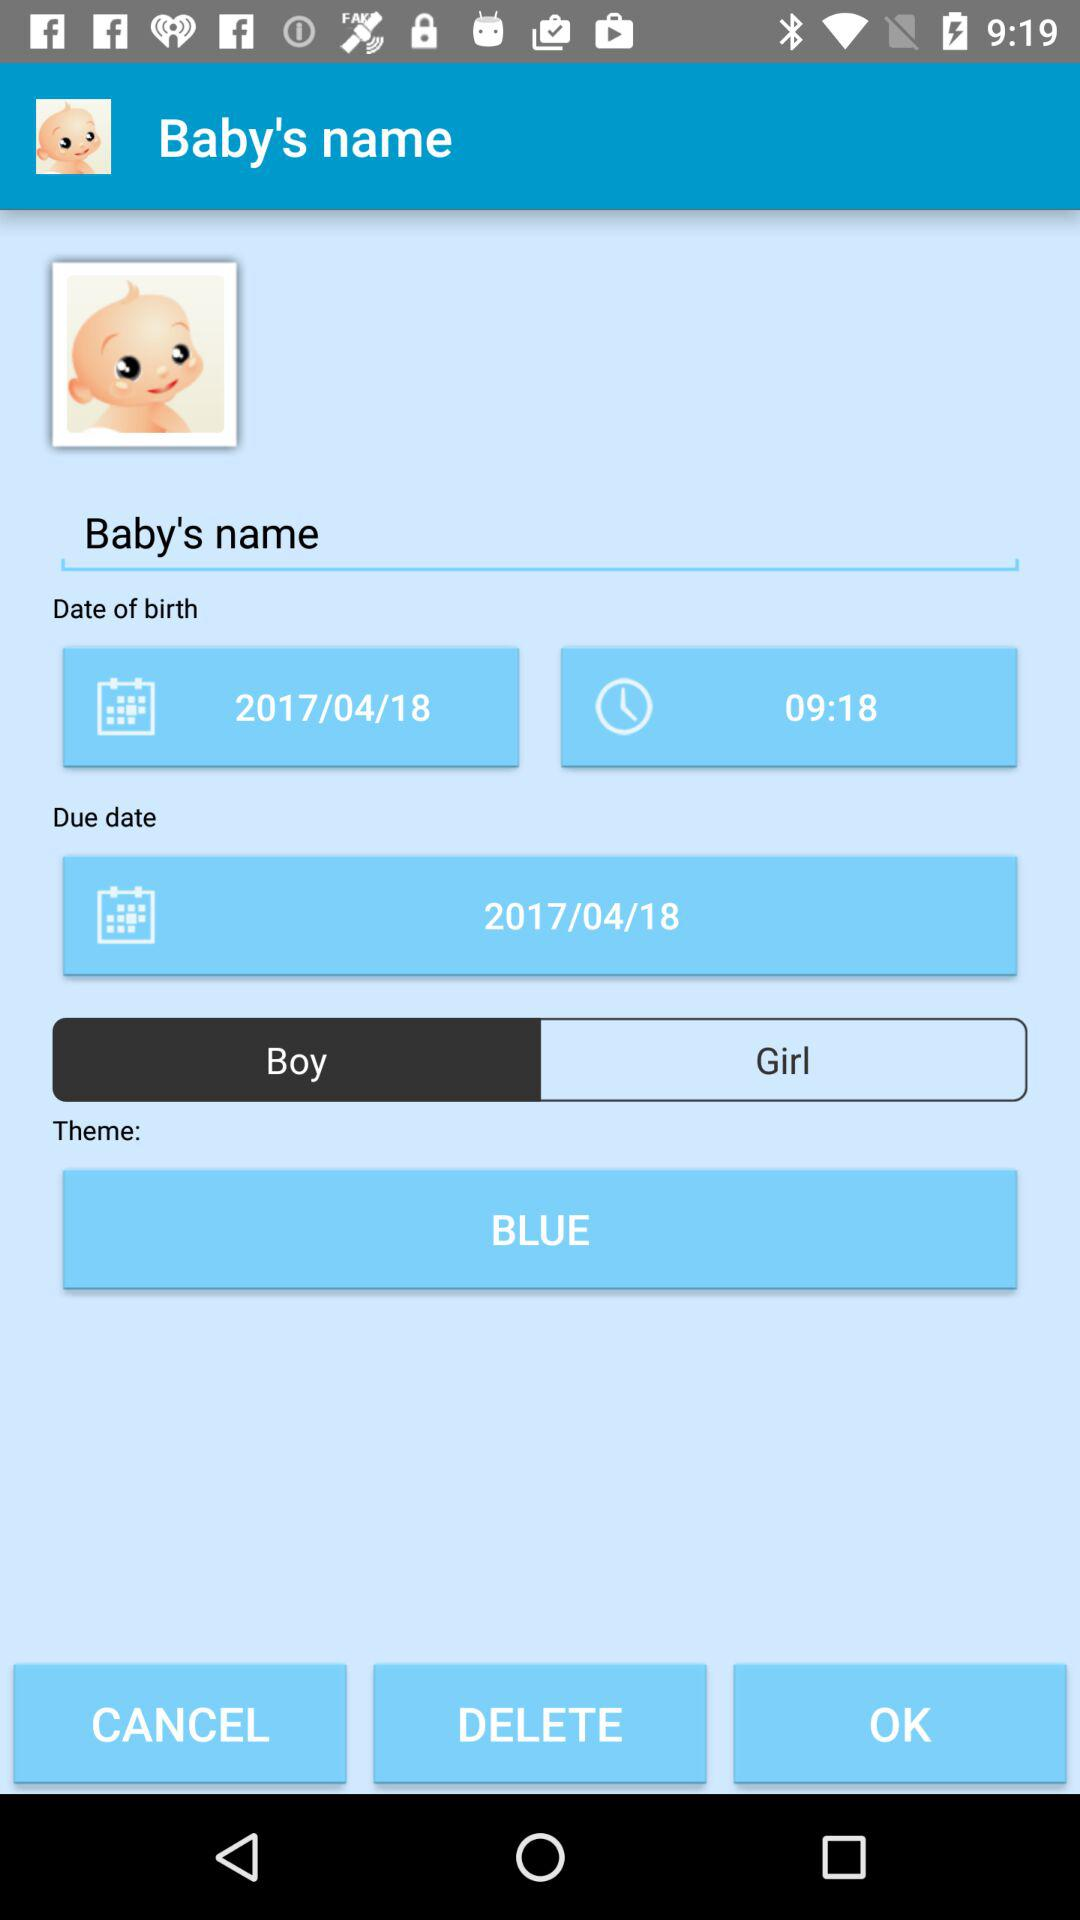What is the given theme color? The given theme color is blue. 